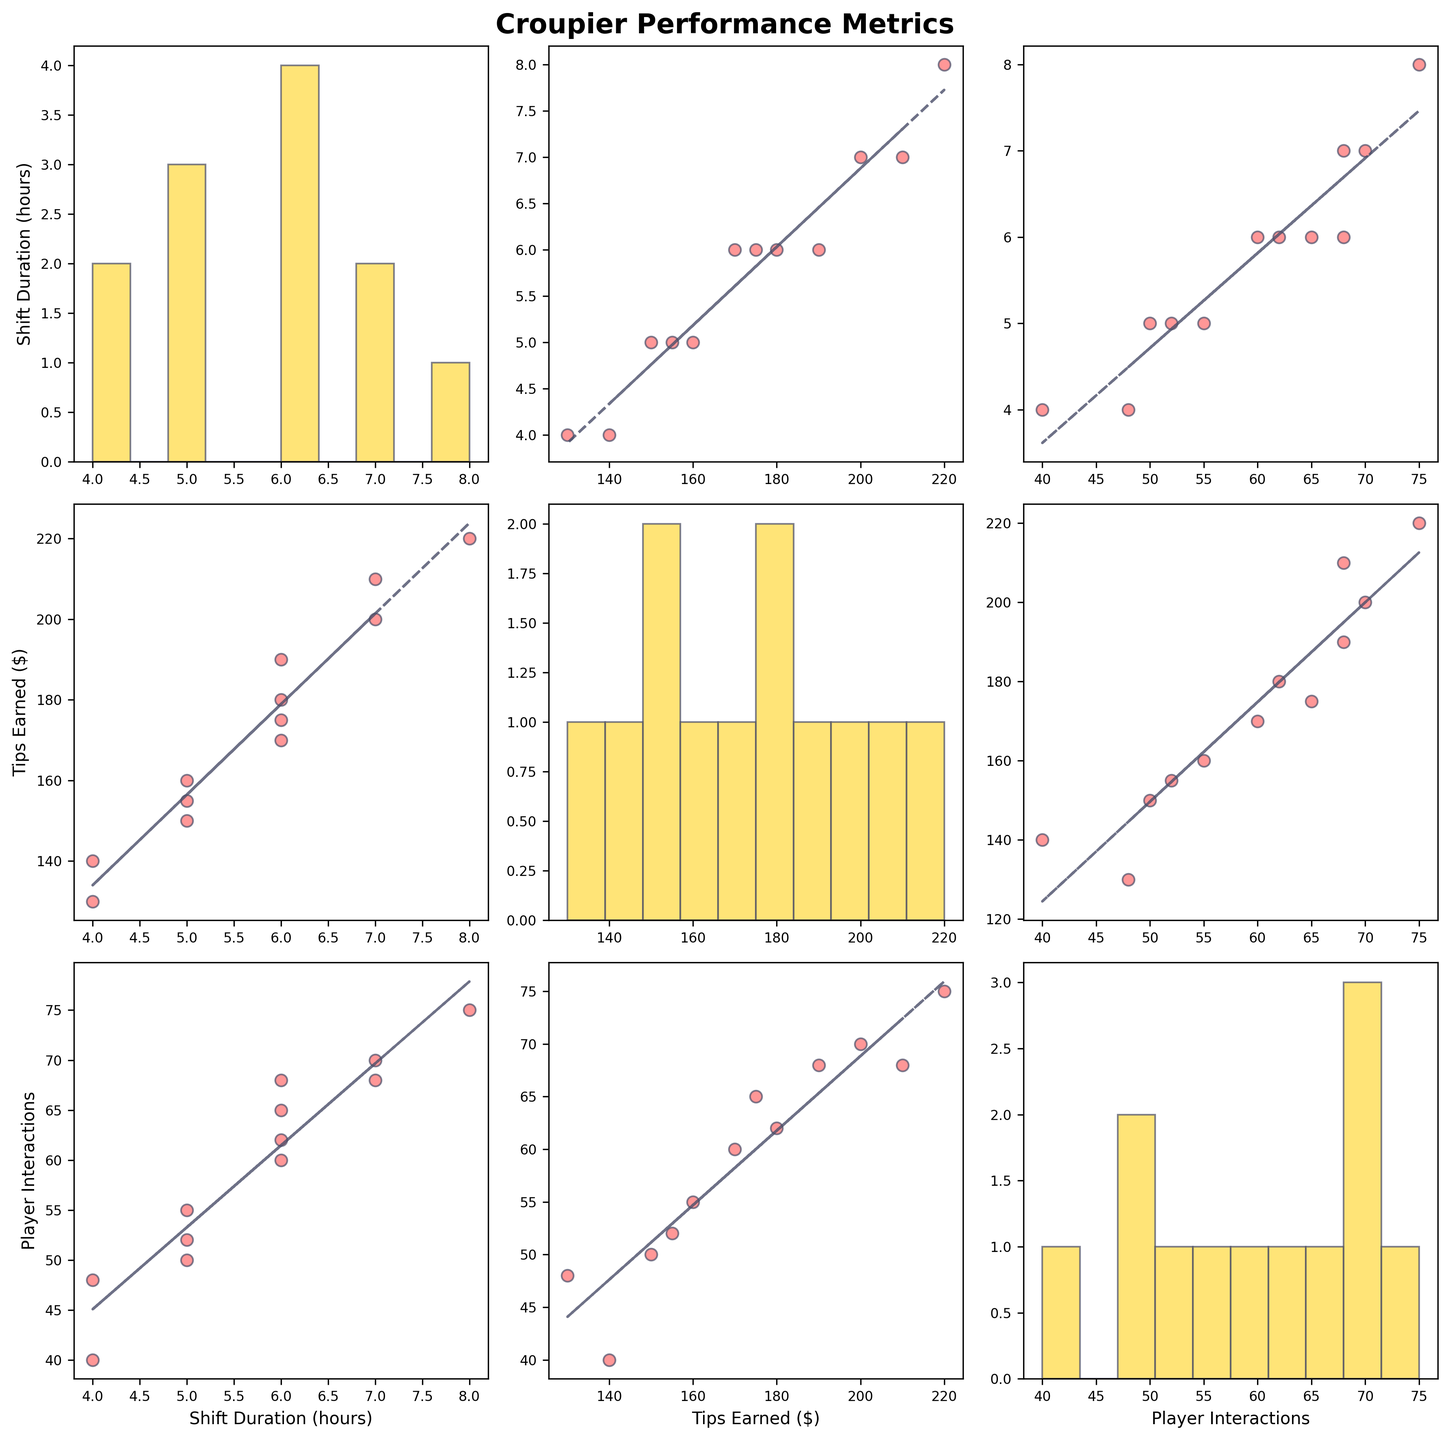What is the title of the figure? The title is located at the top of the figure, which is usually larger and bold to indicate it as the title.
Answer: Croupier Performance Metrics How many metrics are analyzed in the Scatter Plot Matrix? There are three metrics analyzed, one per each row and column of the SPLOM.
Answer: 3 What colors are used for the scatter points and the diagonal histograms? The scatter points are a shade of red with edge colors while the histograms on the diagonal are a shade of yellow.
Answer: Scatter points: red; Histograms: yellow Which pair of metrics seem to have the strongest linear relationship? By observing the scatter plots and the fitted trend lines, the pair with the most aligned data points around the trend line indicates the strongest linear relationship.
Answer: Shift Duration and Tips Earned How many croupiers had a shift duration of 6 hours? By examining the histogram for Shift Duration on the diagonal, we count the number of occurrences at the value 6.
Answer: 4 Which scatter plot shows the relationship between Player Interactions and Tips Earned? Locate the intersection of the row for Player Interactions and the column for Tips Earned to find the appropriate scatter plot.
Answer: The middle cell of the last row Is there a trend line included in the scatter plots? By visually inspecting any of the off-diagonal scatter plots, you can see an additional line that represents a trend.
Answer: Yes What's the average number of player interactions for shifts longer than 6 hours? Identify data points with Shift Duration > 6, then compute the average of their Player Interactions. Shifts longer than 6 hours occur at 7 and 8 hours. The corresponding Player Interactions are (70, 68) for 7 hours and (75) for 8 hours, i.e. (70 + 68 + 75)/3.
Answer: 71 Compare the maximum tips earned for shift durations of 5 and 6 hours. To find the maximum tips for shift durations of 5 and 6 hours, count the tips at these durations and compare their highest values. For shift duration 5 hours: (150, 160, 155), maximum is 160. For shift duration 6 hours: (175, 190, 180, 170), maximum is 190.
Answer: 5 hours: 160; 6 hours: 190 